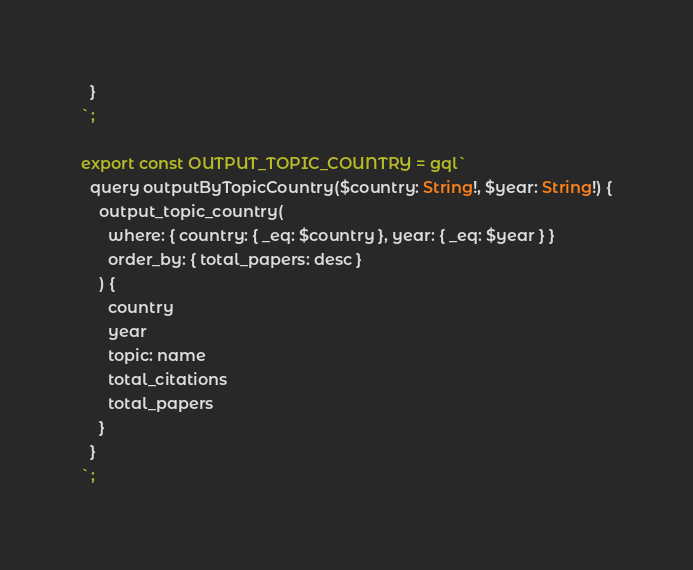Convert code to text. <code><loc_0><loc_0><loc_500><loc_500><_JavaScript_>  }
`;

export const OUTPUT_TOPIC_COUNTRY = gql`
  query outputByTopicCountry($country: String!, $year: String!) {
    output_topic_country(
      where: { country: { _eq: $country }, year: { _eq: $year } }
      order_by: { total_papers: desc }
    ) {
      country
      year
      topic: name
      total_citations
      total_papers
    }
  }
`;
</code> 